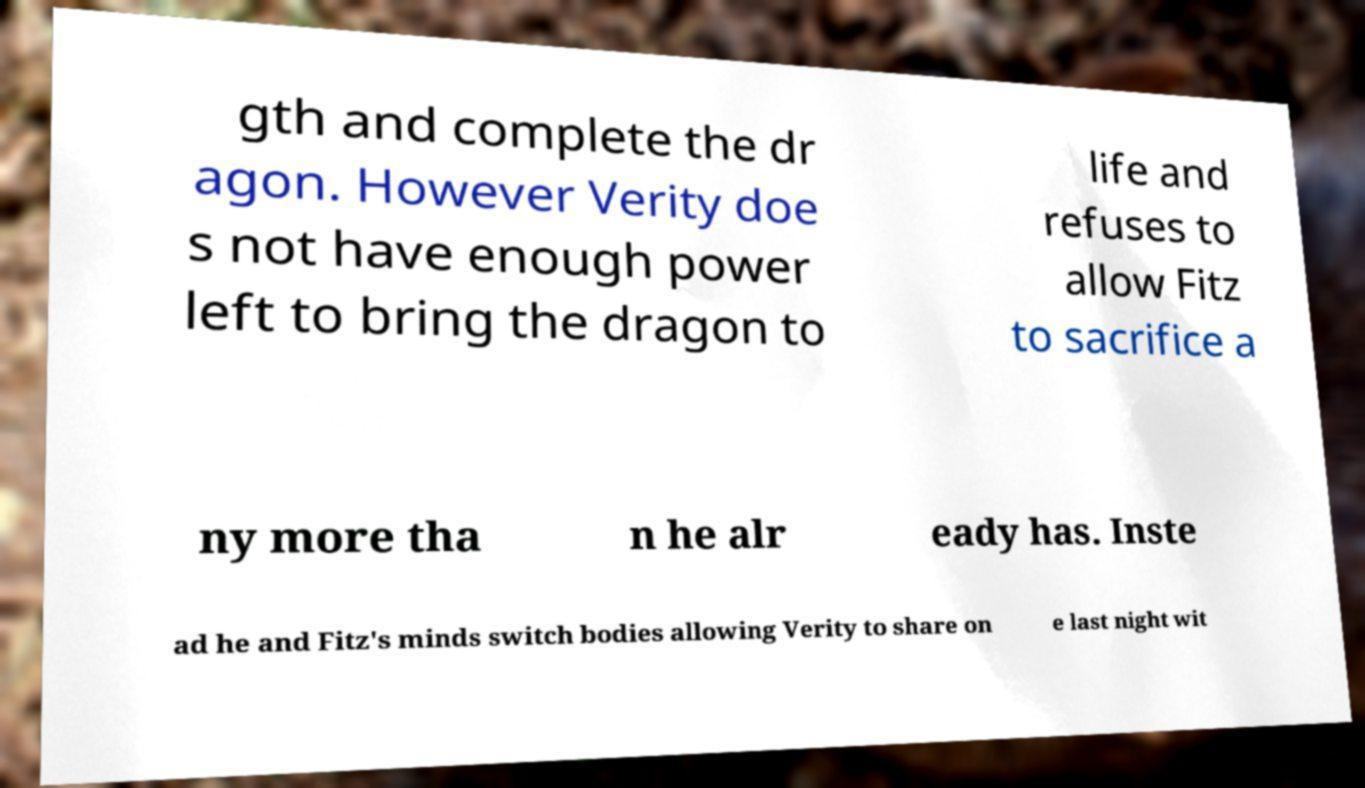Could you assist in decoding the text presented in this image and type it out clearly? gth and complete the dr agon. However Verity doe s not have enough power left to bring the dragon to life and refuses to allow Fitz to sacrifice a ny more tha n he alr eady has. Inste ad he and Fitz's minds switch bodies allowing Verity to share on e last night wit 